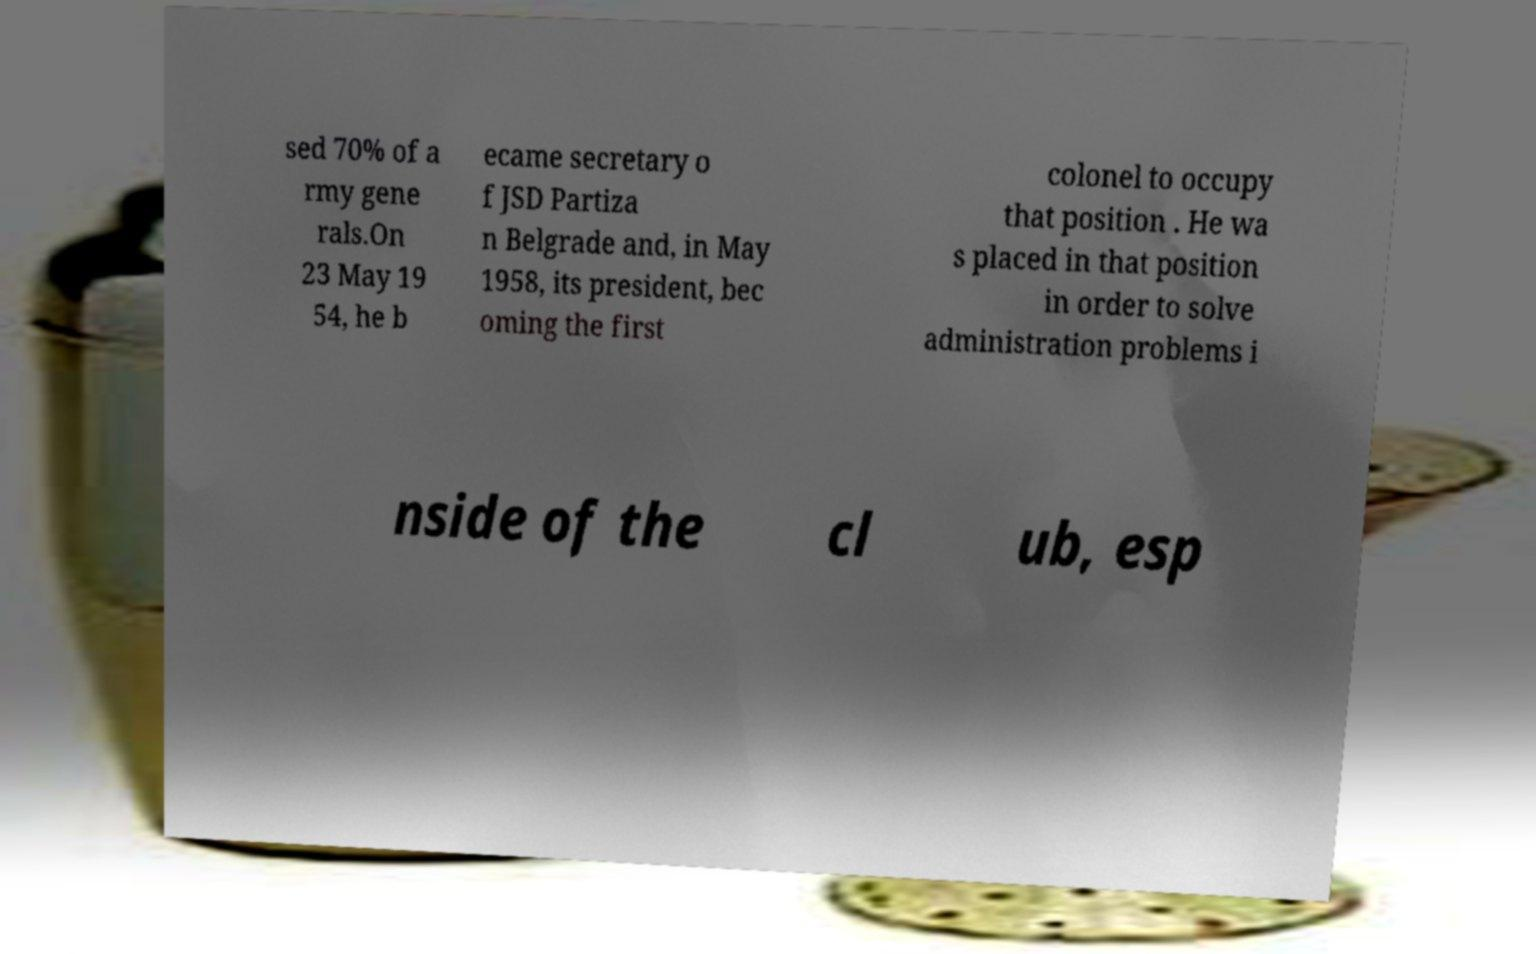Could you extract and type out the text from this image? sed 70% of a rmy gene rals.On 23 May 19 54, he b ecame secretary o f JSD Partiza n Belgrade and, in May 1958, its president, bec oming the first colonel to occupy that position . He wa s placed in that position in order to solve administration problems i nside of the cl ub, esp 